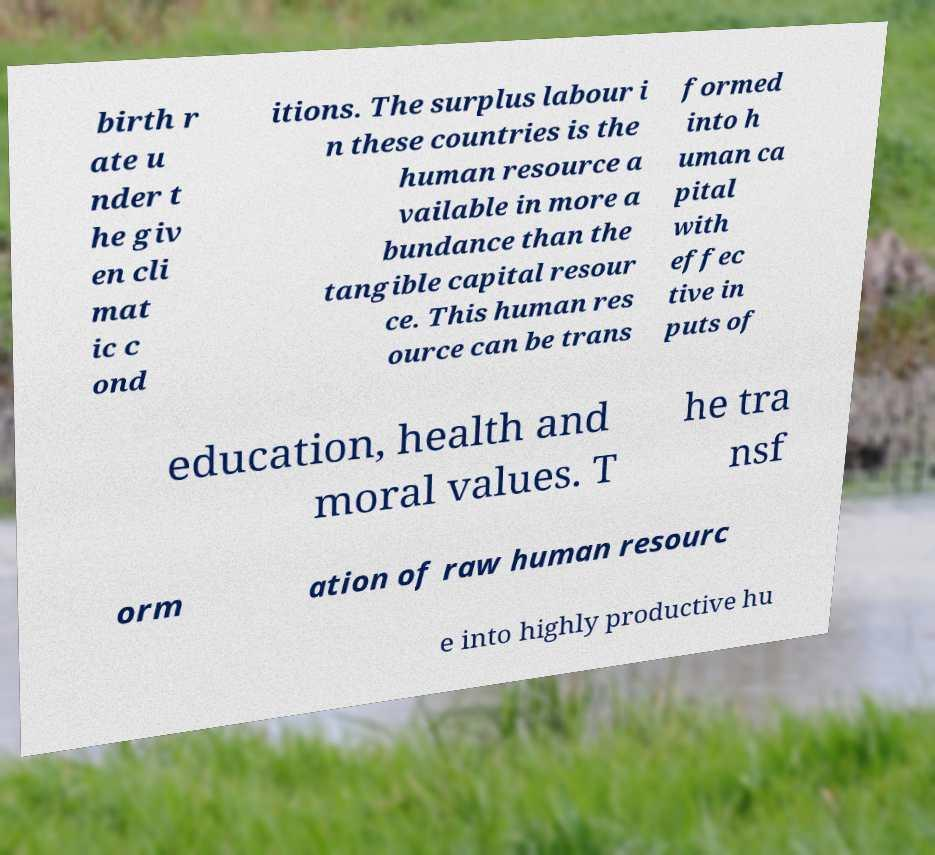For documentation purposes, I need the text within this image transcribed. Could you provide that? birth r ate u nder t he giv en cli mat ic c ond itions. The surplus labour i n these countries is the human resource a vailable in more a bundance than the tangible capital resour ce. This human res ource can be trans formed into h uman ca pital with effec tive in puts of education, health and moral values. T he tra nsf orm ation of raw human resourc e into highly productive hu 